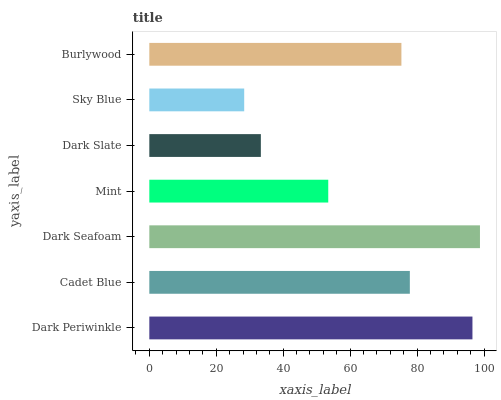Is Sky Blue the minimum?
Answer yes or no. Yes. Is Dark Seafoam the maximum?
Answer yes or no. Yes. Is Cadet Blue the minimum?
Answer yes or no. No. Is Cadet Blue the maximum?
Answer yes or no. No. Is Dark Periwinkle greater than Cadet Blue?
Answer yes or no. Yes. Is Cadet Blue less than Dark Periwinkle?
Answer yes or no. Yes. Is Cadet Blue greater than Dark Periwinkle?
Answer yes or no. No. Is Dark Periwinkle less than Cadet Blue?
Answer yes or no. No. Is Burlywood the high median?
Answer yes or no. Yes. Is Burlywood the low median?
Answer yes or no. Yes. Is Dark Seafoam the high median?
Answer yes or no. No. Is Dark Slate the low median?
Answer yes or no. No. 